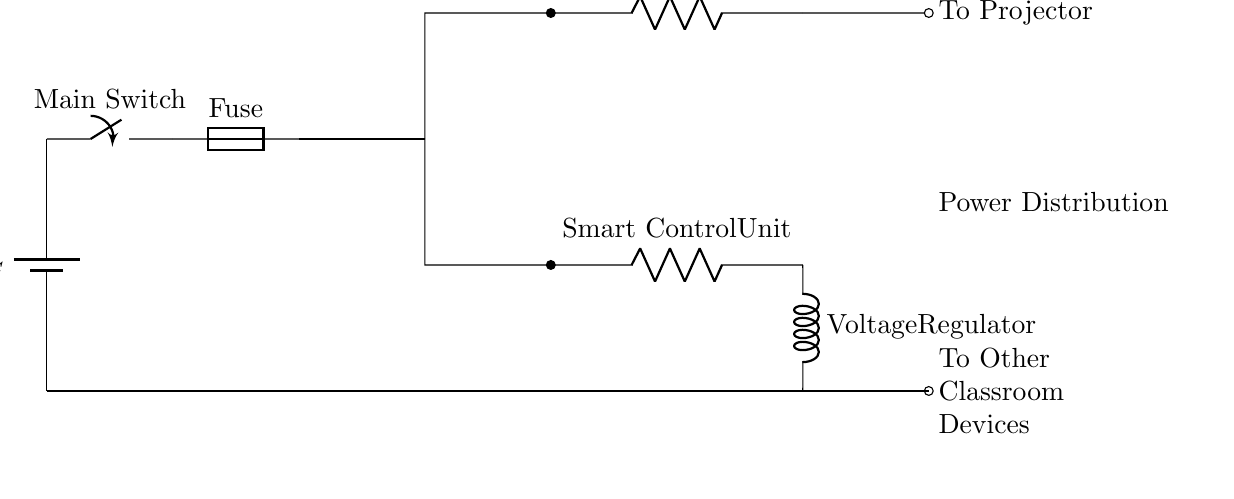What is the voltage supplied to the circuit? The circuit is powered by a 120V AC battery, as indicated at the top left of the diagram.
Answer: 120V AC What component is labeled as the main switch? The main switch is represented in the circuit by the switch symbol positioned between the battery and the fuse. It is labeled "Main Switch."
Answer: Main Switch What does the fuse do in this circuit? The fuse is designed to protect the circuit from overcurrent, and is located directly after the main switch. This is critical for safety in high power applications.
Answer: Protects from overcurrent What device connects to the projector power supply? The "To Projector" label shows that the projector power supply is connected to the projector. This is an important connection in the system's functionality.
Answer: Projector How many devices are powered from this circuit setup? The setup includes two main load devices: the projector and the smart control unit, indicated by their placement in the circuit.
Answer: Two What is the role of the voltage regulator? The voltage regulator ensures that the voltage supplied to other classroom devices remains stable, despite variations in input from the main circuit, which is crucial for sensitive electronic devices.
Answer: Stabilizes voltage What is indicated by the ground connection in this circuit? The ground connection provides a reference point for the voltage in the circuit and helps in safely dissipating excess current, reducing the risk of electrical shock or damage.
Answer: Safety reference 